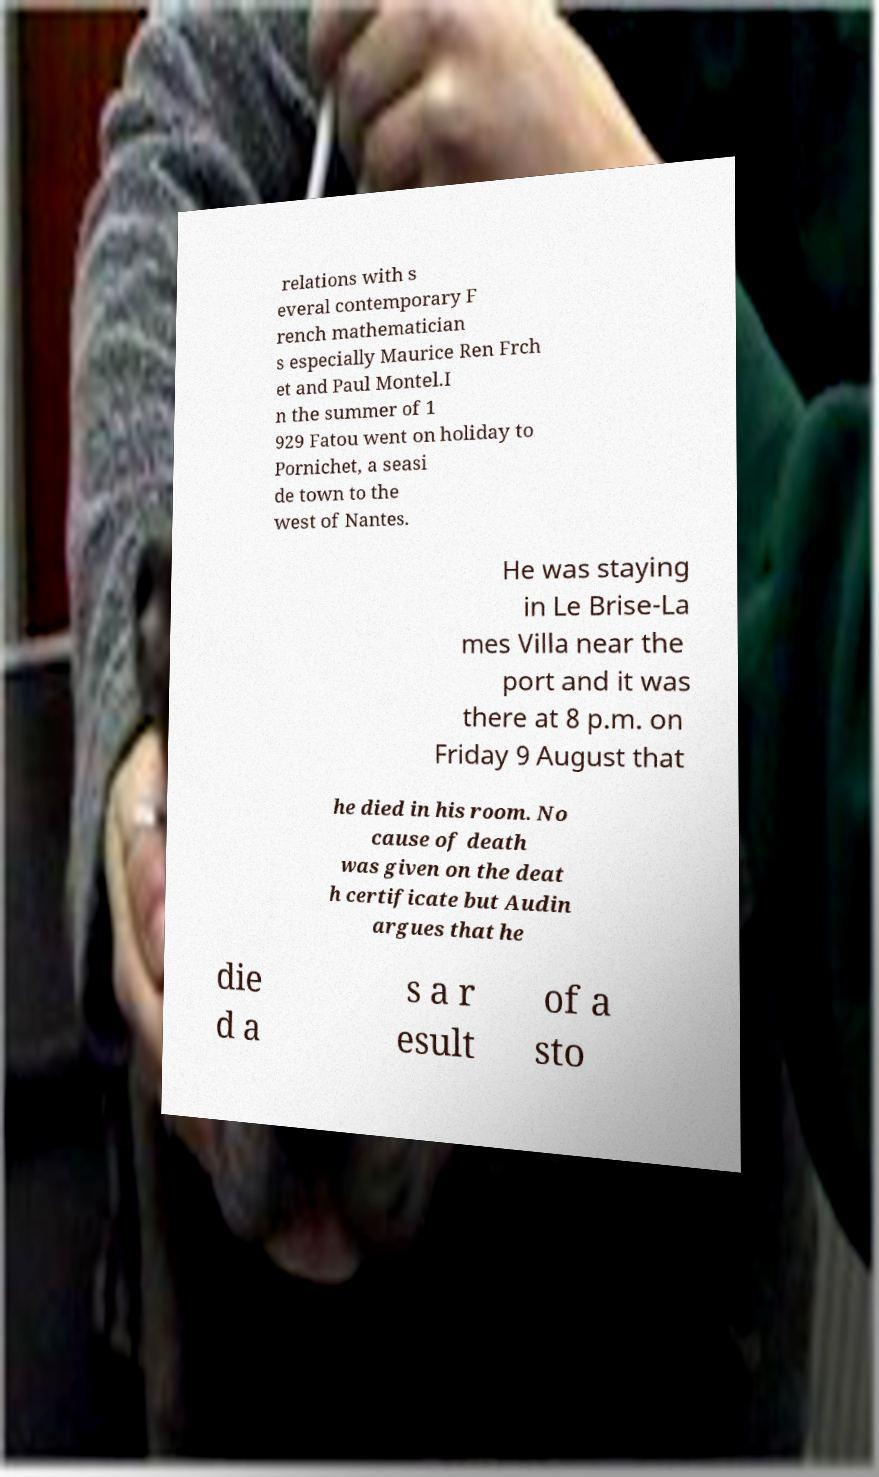Can you read and provide the text displayed in the image?This photo seems to have some interesting text. Can you extract and type it out for me? relations with s everal contemporary F rench mathematician s especially Maurice Ren Frch et and Paul Montel.I n the summer of 1 929 Fatou went on holiday to Pornichet, a seasi de town to the west of Nantes. He was staying in Le Brise-La mes Villa near the port and it was there at 8 p.m. on Friday 9 August that he died in his room. No cause of death was given on the deat h certificate but Audin argues that he die d a s a r esult of a sto 